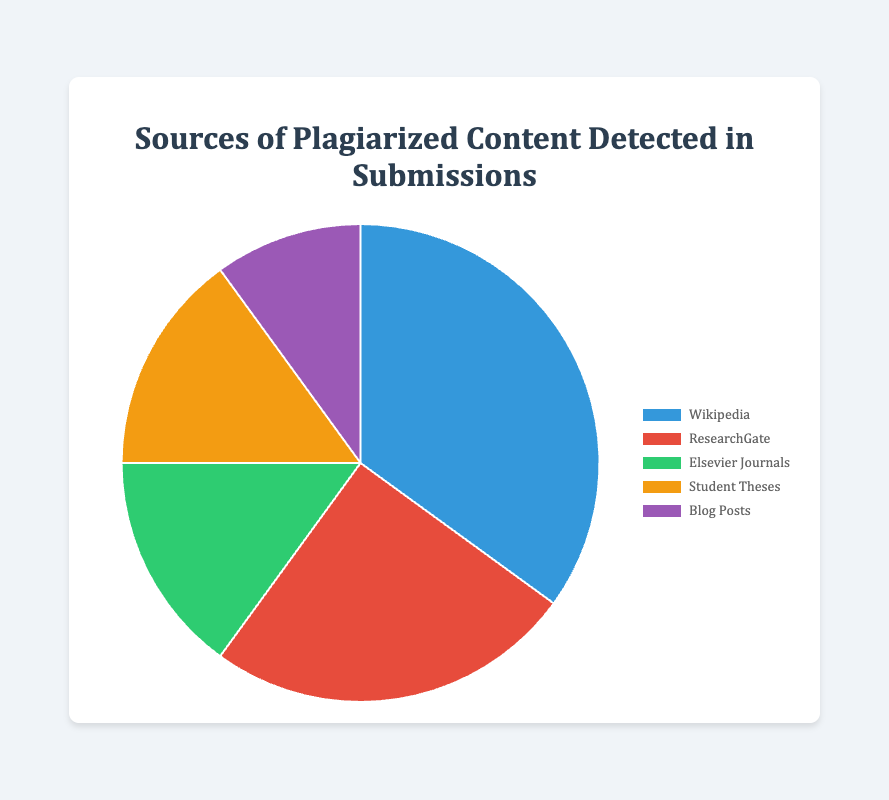What is the most common source of plagiarized content? By examining the pie chart, the segment with the largest area represents the most common source. Wikipedia has the largest segment with 35%.
Answer: Wikipedia How many percent of the plagiarized content comes from ResearchGate and Blog Posts combined? Summing the percentages for ResearchGate (25%) and Blog Posts (10%), we get 25 + 10 = 35%.
Answer: 35% Which source contributes more to plagiarized content: Student Theses or Elsevier Journals? Comparing the segments, both Student Theses and Elsevier Journals have the same percentage of 15%. Therefore, neither contributes more.
Answer: They contribute equally What is the difference in percentage between the largest source and the smallest source of plagiarized content? The largest percentage is from Wikipedia (35%) and the smallest is from Blog Posts (10%). The difference is calculated as 35 - 10 = 25%.
Answer: 25% What's the average percentage contribution of Elsevier Journals and Student Theses? Summing the percentages for Elsevier Journals (15%) and Student Theses (15%) and then dividing by 2 gives the average as (15 + 15)/2 = 15%.
Answer: 15% Which two sources together account for half of the plagiarized content? Adding the percentages for Wikipedia (35%) and ResearchGate (25%) gives 35 + 25 = 60%, which is more than half. Next, Wikipedia (35%) and Elsevier Journals (15%) give 35 + 15 = 50%, which is exactly half.
Answer: Wikipedia and Elsevier Journals Based on visual inspection, what color corresponds to the segment representing Blog Posts? By looking at the color legend alongside the pie chart, Blog Posts is represented by the purple segment.
Answer: Purple Is the percentage of plagiarized content from Wikipedia greater than the combined percentage from Elsevier Journals and Student Theses? Summing the percentages of Elsevier Journals (15%) and Student Theses (15%) gives 15 + 15 = 30%. Wikipedia alone accounts for 35%, which is greater.
Answer: Yes What is the second largest source of plagiarized content? By comparing the segments visually and noticing the percentages in the pie chart, the second largest source after Wikipedia (35%) is ResearchGate (25%).
Answer: ResearchGate 